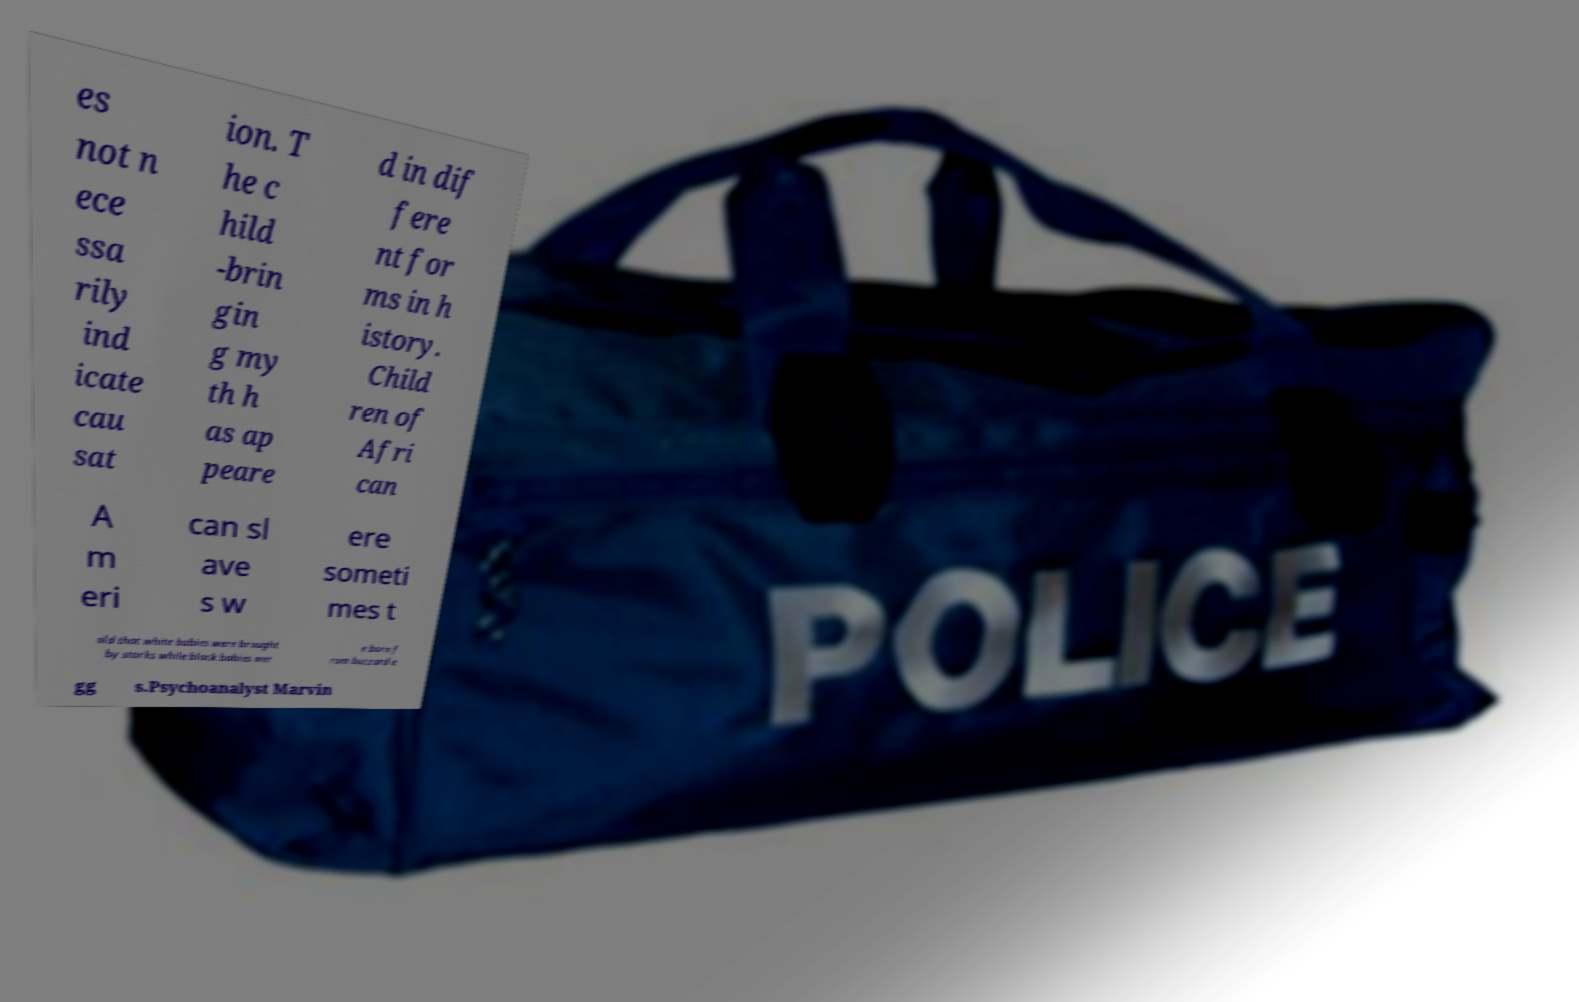What messages or text are displayed in this image? I need them in a readable, typed format. es not n ece ssa rily ind icate cau sat ion. T he c hild -brin gin g my th h as ap peare d in dif fere nt for ms in h istory. Child ren of Afri can A m eri can sl ave s w ere someti mes t old that white babies were brought by storks while black babies wer e born f rom buzzard e gg s.Psychoanalyst Marvin 